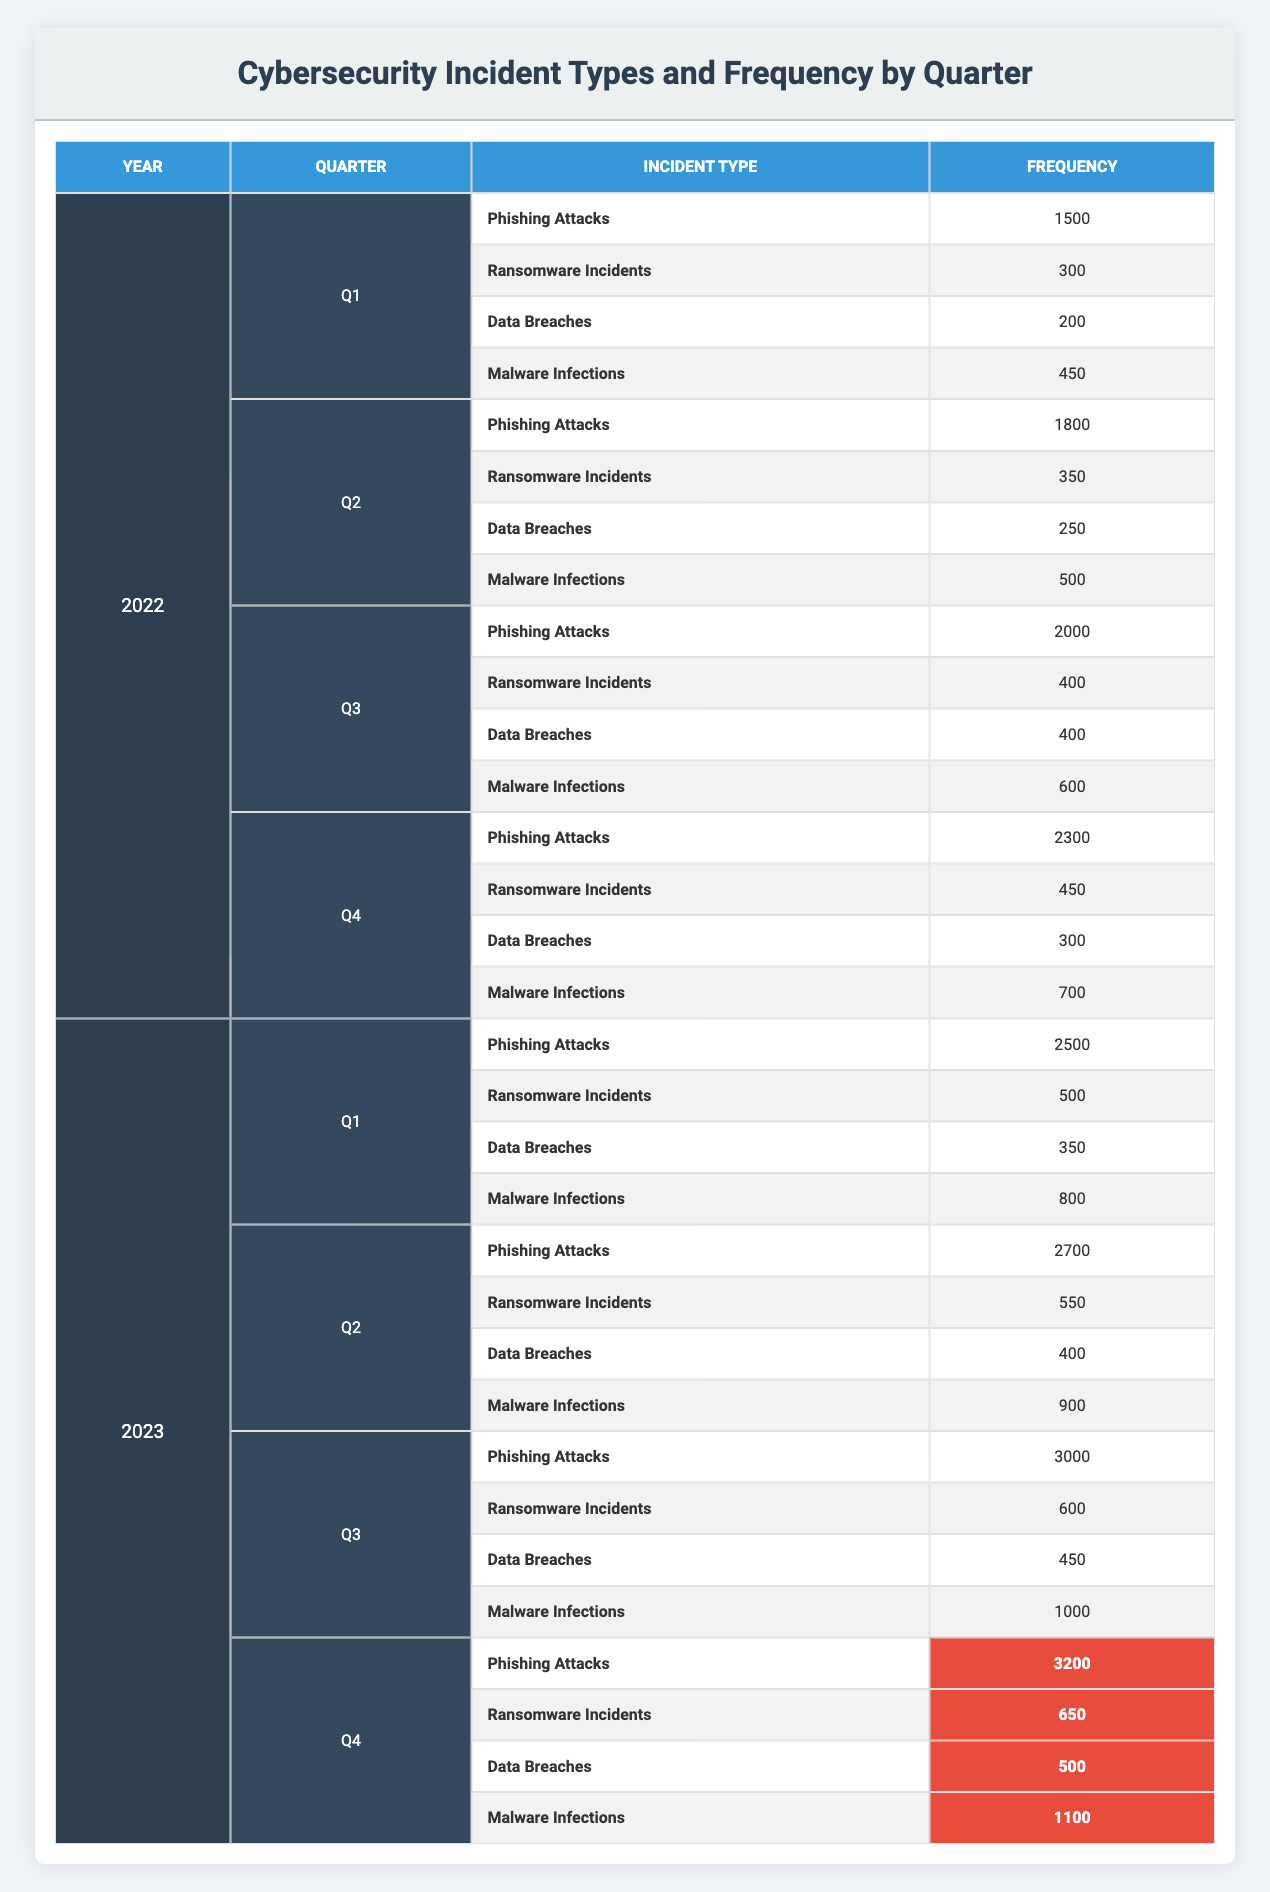What was the total number of Phishing Attacks in 2022? To find the total number of Phishing Attacks in 2022, I need to sum the frequencies across all four quarters: Q1 (1500) + Q2 (1800) + Q3 (2000) + Q4 (2300) = 9600.
Answer: 9600 Which quarter in 2023 experienced the highest number of Ransomware Incidents? By comparing the Ransomware Incidents across all quarters in 2023, I see that Q4 had 650 incidents, which is more than Q1 (500), Q2 (550), and Q3 (600). Therefore, Q4 is the quarter with the highest number.
Answer: Q4 Did Data Breaches increase from Q1 to Q4 in 2023? I need to check the values for Data Breaches in both Q1 (350) and Q4 (500) for 2023. Since 500 is greater than 350, this indicates an increase in Data Breaches.
Answer: Yes What is the average number of Malware Infections for the year 2022? To calculate the average, first, I will sum the Malware Infections across all quarters: Q1 (450) + Q2 (500) + Q3 (600) + Q4 (700) = 2250. Then, divide this sum by the number of quarters (4) to find the average: 2250 / 4 = 562.5.
Answer: 562.5 In which quarter of 2022 did Phishing Attacks first exceed 2000? Looking at Phishing Attacks for each quarter in 2022, Q1 had 1500, Q2 had 1800, Q3 had 2000, and Q4 had 2300. Therefore, Q4 is the first quarter where the number exceeded 2000.
Answer: Q4 What was the percentage increase in Phishing Attacks from Q1 2022 to Q1 2023? First, I identify the values for Phishing Attacks in these quarters: Q1 2022 had 1500 and Q1 2023 had 2500. The difference is 2500 - 1500 = 1000. To find the percentage increase, I calculate (1000 / 1500) * 100 = 66.67%.
Answer: 66.67% Did Malware Infections report a decrease in any quarter from 2022 to 2023? By checking the values for Malware Infections: Q1 2022 (450), Q1 2023 (800), Q2 2022 (500), Q2 2023 (900), Q3 2022 (600), Q3 2023 (1000), Q4 2022 (700), and Q4 2023 (1100). All the values in 2023 are higher than 2022, so there were no decreases.
Answer: No What is the total number of Cybersecurity Incidents reported in Q2 2023? To find the total for Q2 2023, I sum the incidents: Phishing Attacks (2700) + Ransomware Incidents (550) + Data Breaches (400) + Malware Infections (900) = 4550.
Answer: 4550 